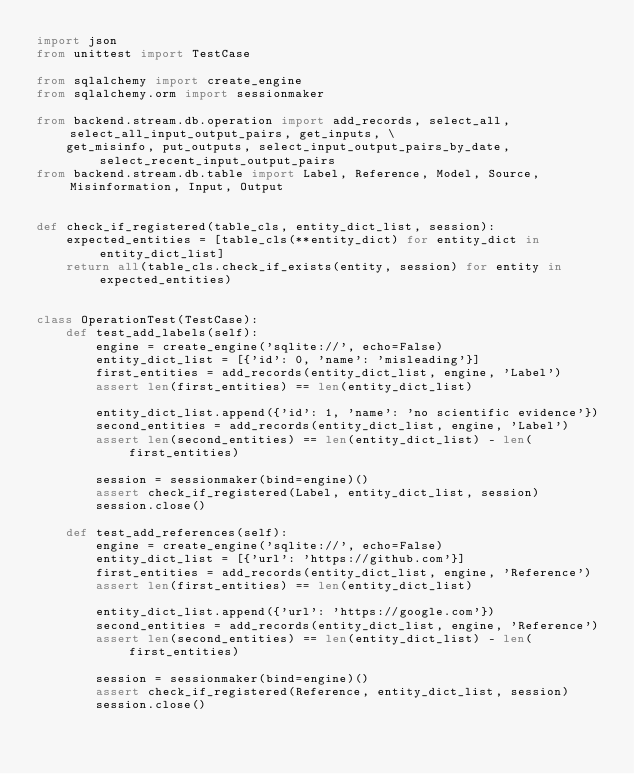Convert code to text. <code><loc_0><loc_0><loc_500><loc_500><_Python_>import json
from unittest import TestCase

from sqlalchemy import create_engine
from sqlalchemy.orm import sessionmaker

from backend.stream.db.operation import add_records, select_all, select_all_input_output_pairs, get_inputs, \
    get_misinfo, put_outputs, select_input_output_pairs_by_date, select_recent_input_output_pairs
from backend.stream.db.table import Label, Reference, Model, Source, Misinformation, Input, Output


def check_if_registered(table_cls, entity_dict_list, session):
    expected_entities = [table_cls(**entity_dict) for entity_dict in entity_dict_list]
    return all(table_cls.check_if_exists(entity, session) for entity in expected_entities)


class OperationTest(TestCase):
    def test_add_labels(self):
        engine = create_engine('sqlite://', echo=False)
        entity_dict_list = [{'id': 0, 'name': 'misleading'}]
        first_entities = add_records(entity_dict_list, engine, 'Label')
        assert len(first_entities) == len(entity_dict_list)

        entity_dict_list.append({'id': 1, 'name': 'no scientific evidence'})
        second_entities = add_records(entity_dict_list, engine, 'Label')
        assert len(second_entities) == len(entity_dict_list) - len(first_entities)

        session = sessionmaker(bind=engine)()
        assert check_if_registered(Label, entity_dict_list, session)
        session.close()

    def test_add_references(self):
        engine = create_engine('sqlite://', echo=False)
        entity_dict_list = [{'url': 'https://github.com'}]
        first_entities = add_records(entity_dict_list, engine, 'Reference')
        assert len(first_entities) == len(entity_dict_list)

        entity_dict_list.append({'url': 'https://google.com'})
        second_entities = add_records(entity_dict_list, engine, 'Reference')
        assert len(second_entities) == len(entity_dict_list) - len(first_entities)

        session = sessionmaker(bind=engine)()
        assert check_if_registered(Reference, entity_dict_list, session)
        session.close()
</code> 